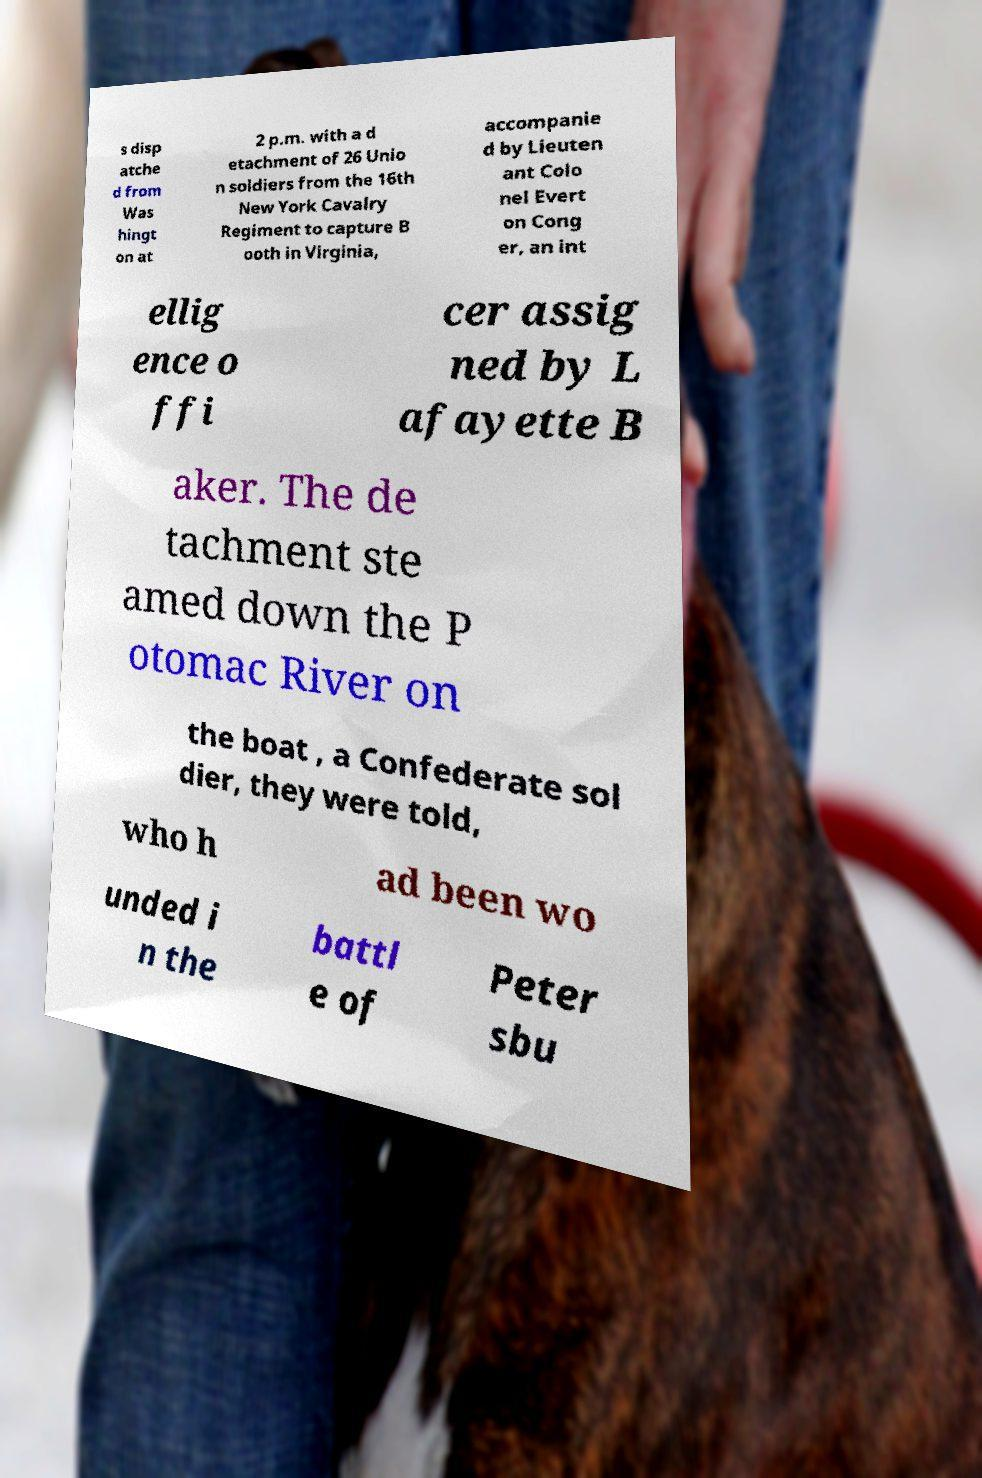Please read and relay the text visible in this image. What does it say? s disp atche d from Was hingt on at 2 p.m. with a d etachment of 26 Unio n soldiers from the 16th New York Cavalry Regiment to capture B ooth in Virginia, accompanie d by Lieuten ant Colo nel Evert on Cong er, an int ellig ence o ffi cer assig ned by L afayette B aker. The de tachment ste amed down the P otomac River on the boat , a Confederate sol dier, they were told, who h ad been wo unded i n the battl e of Peter sbu 